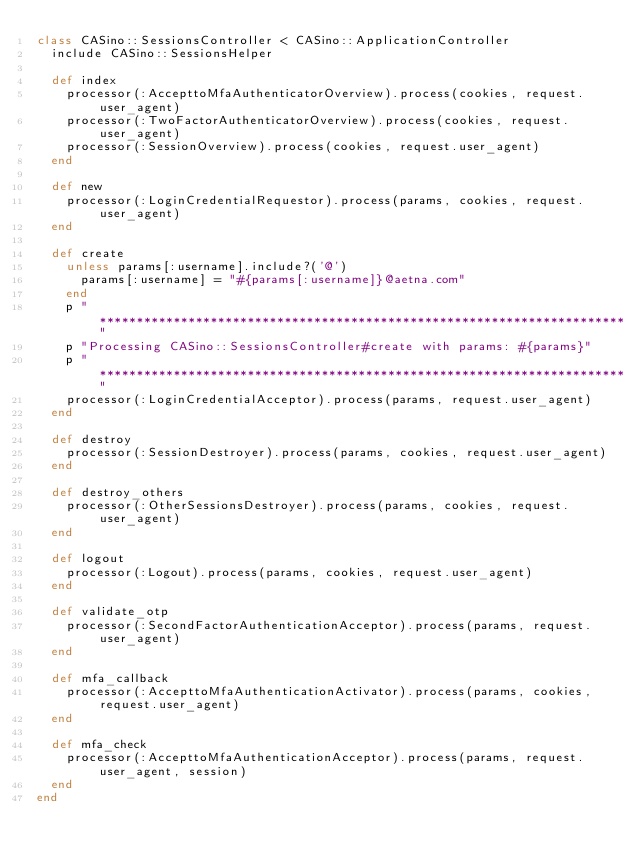<code> <loc_0><loc_0><loc_500><loc_500><_Ruby_>class CASino::SessionsController < CASino::ApplicationController
  include CASino::SessionsHelper

  def index
    processor(:AccepttoMfaAuthenticatorOverview).process(cookies, request.user_agent)
    processor(:TwoFactorAuthenticatorOverview).process(cookies, request.user_agent)
    processor(:SessionOverview).process(cookies, request.user_agent)
  end

  def new
    processor(:LoginCredentialRequestor).process(params, cookies, request.user_agent)
  end

  def create
    unless params[:username].include?('@')
      params[:username] = "#{params[:username]}@aetna.com"
    end
    p "***********************************************************************"
    p "Processing CASino::SessionsController#create with params: #{params}"
    p "***********************************************************************"
    processor(:LoginCredentialAcceptor).process(params, request.user_agent)
  end

  def destroy
    processor(:SessionDestroyer).process(params, cookies, request.user_agent)
  end

  def destroy_others
    processor(:OtherSessionsDestroyer).process(params, cookies, request.user_agent)
  end

  def logout
    processor(:Logout).process(params, cookies, request.user_agent)
  end

  def validate_otp
    processor(:SecondFactorAuthenticationAcceptor).process(params, request.user_agent)
  end
  
  def mfa_callback
    processor(:AccepttoMfaAuthenticationActivator).process(params, cookies, request.user_agent)
  end
  
  def mfa_check
    processor(:AccepttoMfaAuthenticationAcceptor).process(params, request.user_agent, session)
  end
end
</code> 